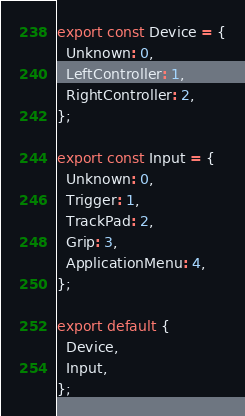Convert code to text. <code><loc_0><loc_0><loc_500><loc_500><_JavaScript_>export const Device = {
  Unknown: 0,
  LeftController: 1,
  RightController: 2,
};

export const Input = {
  Unknown: 0,
  Trigger: 1,
  TrackPad: 2,
  Grip: 3,
  ApplicationMenu: 4,
};

export default {
  Device,
  Input,
};
</code> 